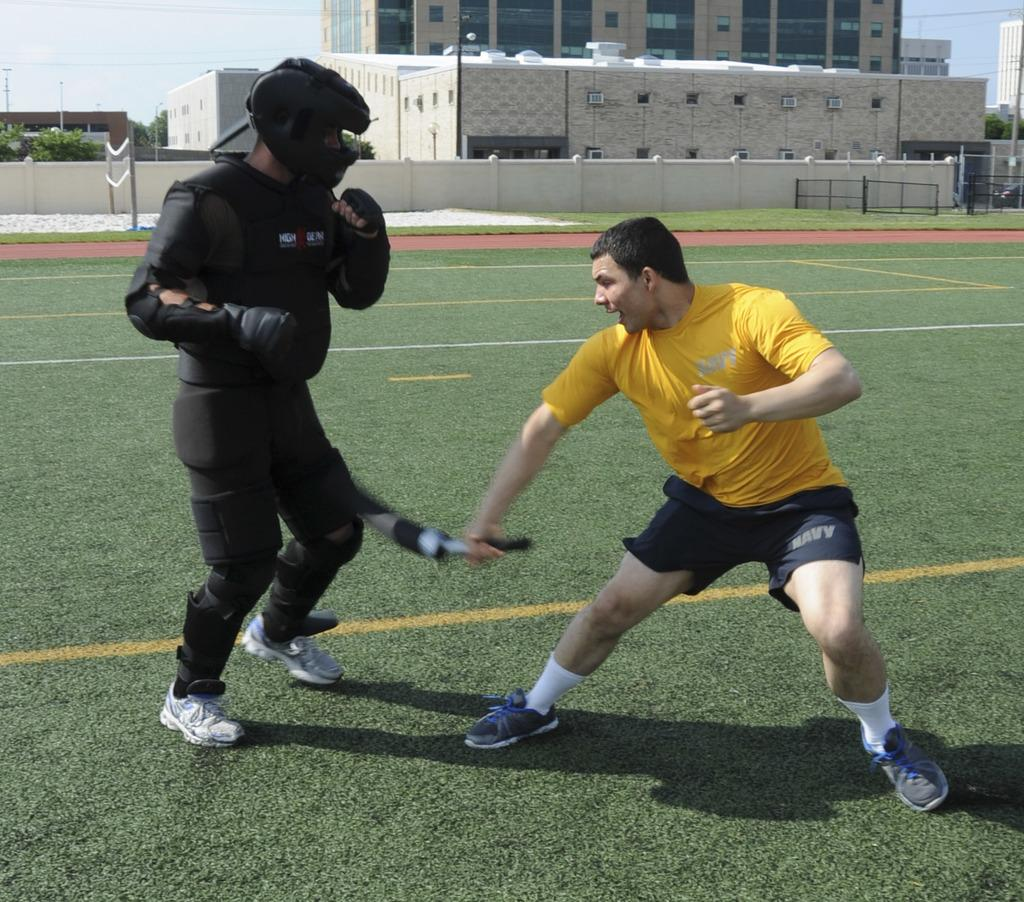<image>
Summarize the visual content of the image. two men in a gras sfield one in black and one in yellow and blue shorts with NAVY written on them 